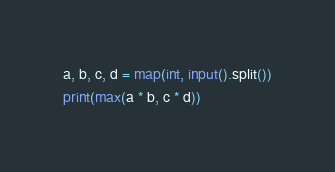<code> <loc_0><loc_0><loc_500><loc_500><_Python_>a, b, c, d = map(int, input().split())
print(max(a * b, c * d))</code> 